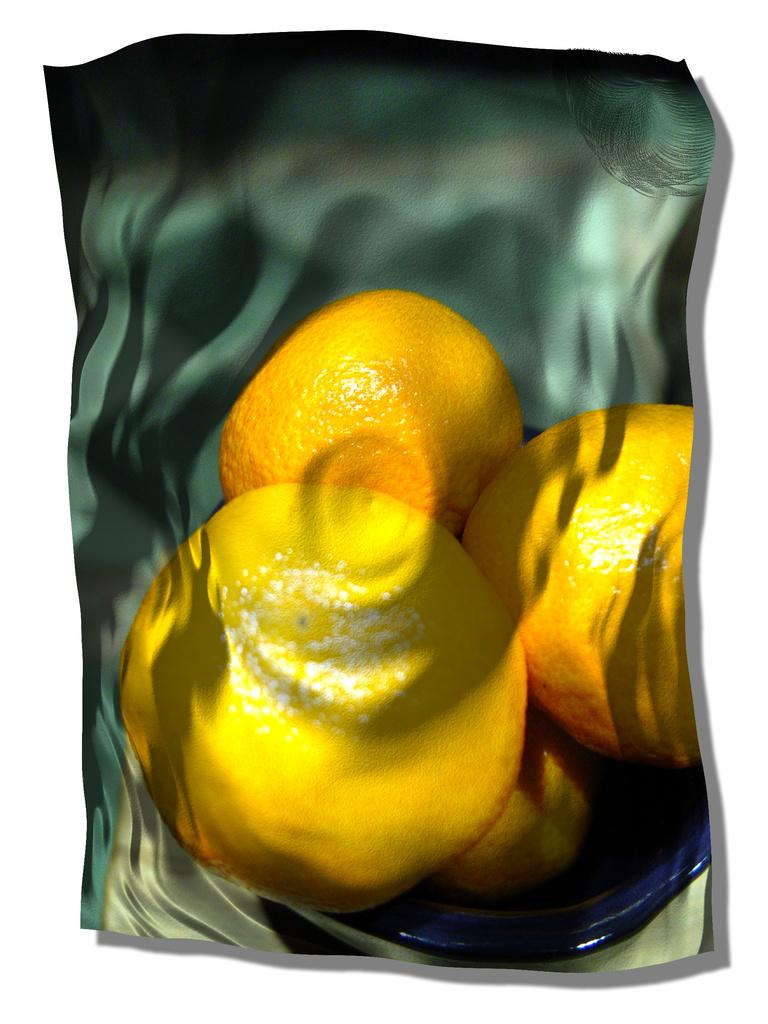How many oranges are visible in the image? There are three oranges in the image. Where are the oranges located in the image? The oranges are in a bowl. What type of shade is provided by the oranges in the image? There is no shade provided by the oranges in the image, as they are inanimate objects and do not offer shade. 